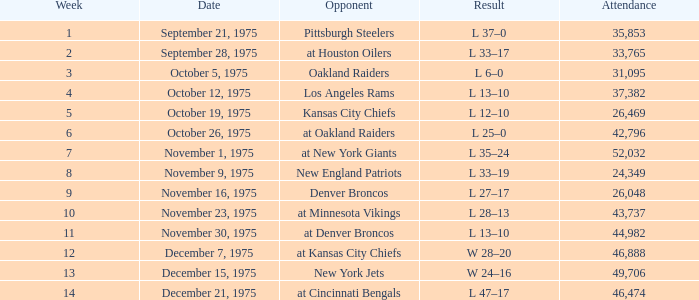When did the earliest week occur with a 6-0 outcome? 3.0. 